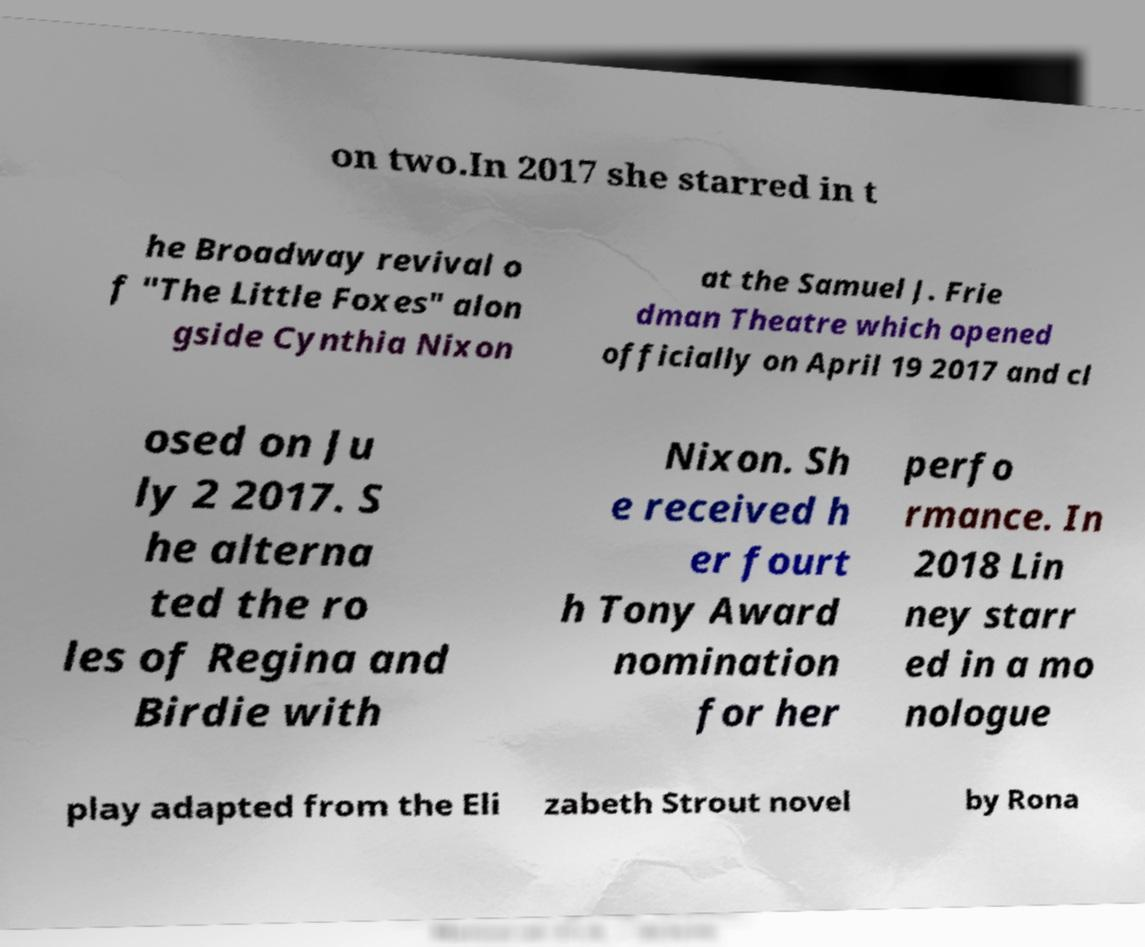Can you read and provide the text displayed in the image?This photo seems to have some interesting text. Can you extract and type it out for me? on two.In 2017 she starred in t he Broadway revival o f "The Little Foxes" alon gside Cynthia Nixon at the Samuel J. Frie dman Theatre which opened officially on April 19 2017 and cl osed on Ju ly 2 2017. S he alterna ted the ro les of Regina and Birdie with Nixon. Sh e received h er fourt h Tony Award nomination for her perfo rmance. In 2018 Lin ney starr ed in a mo nologue play adapted from the Eli zabeth Strout novel by Rona 